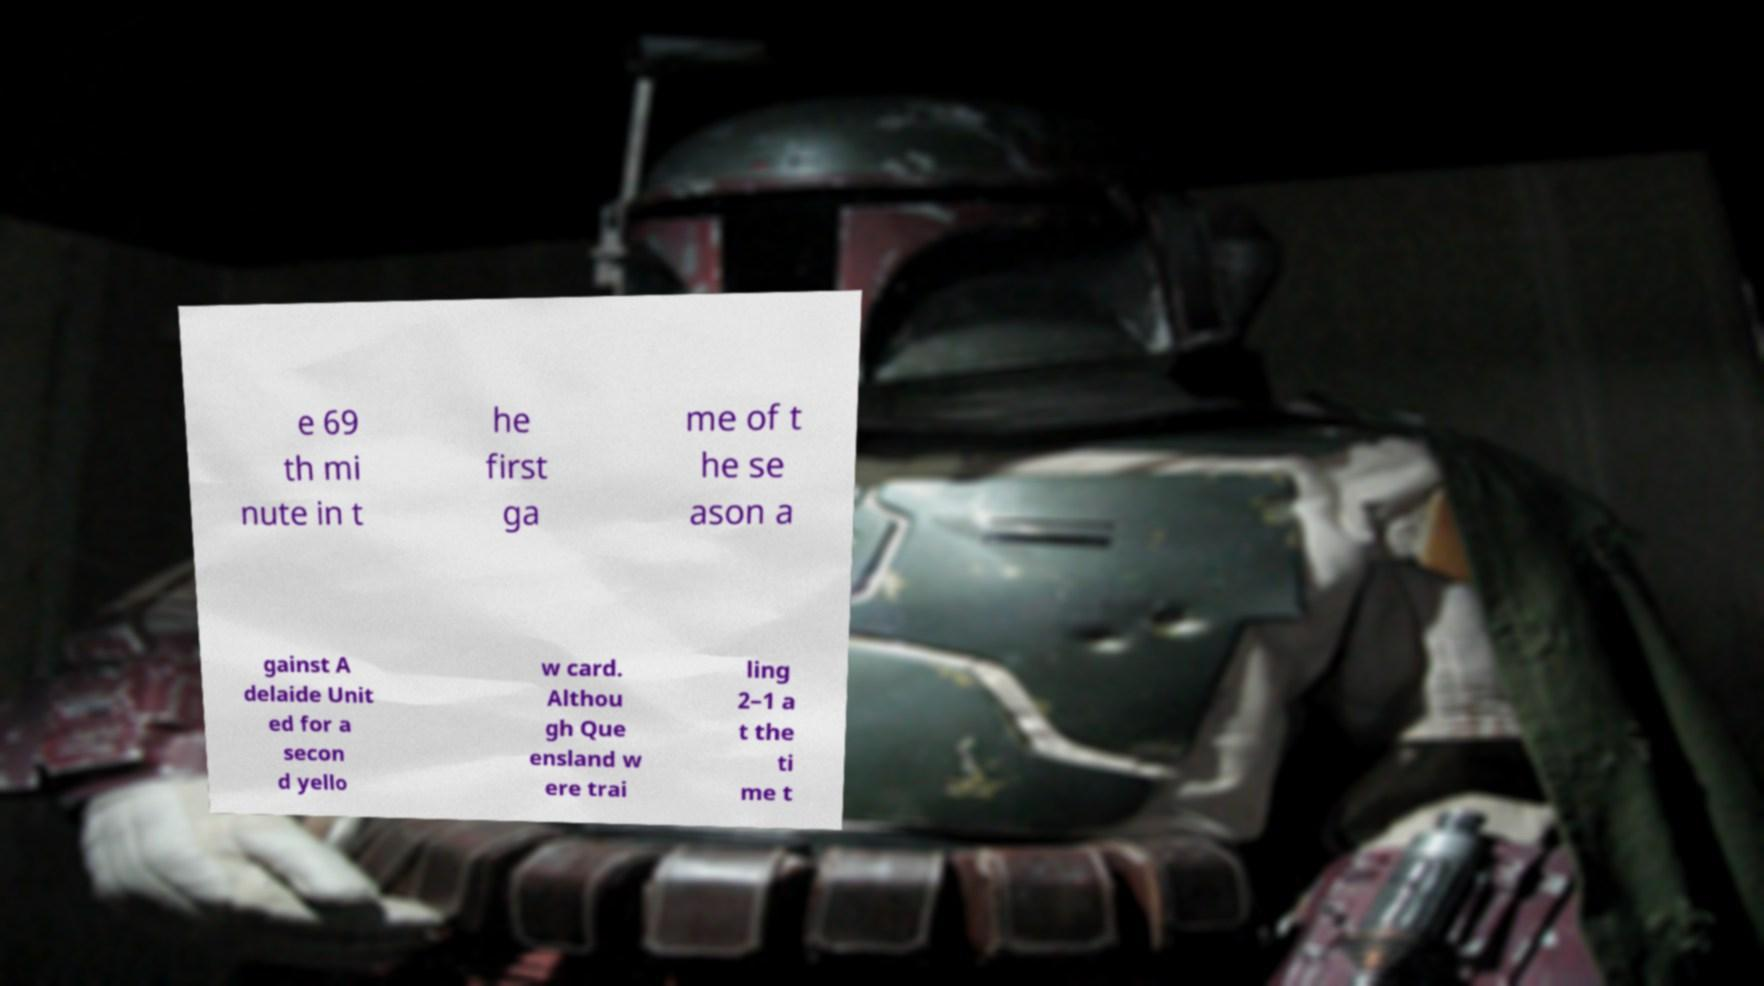Can you read and provide the text displayed in the image?This photo seems to have some interesting text. Can you extract and type it out for me? e 69 th mi nute in t he first ga me of t he se ason a gainst A delaide Unit ed for a secon d yello w card. Althou gh Que ensland w ere trai ling 2–1 a t the ti me t 